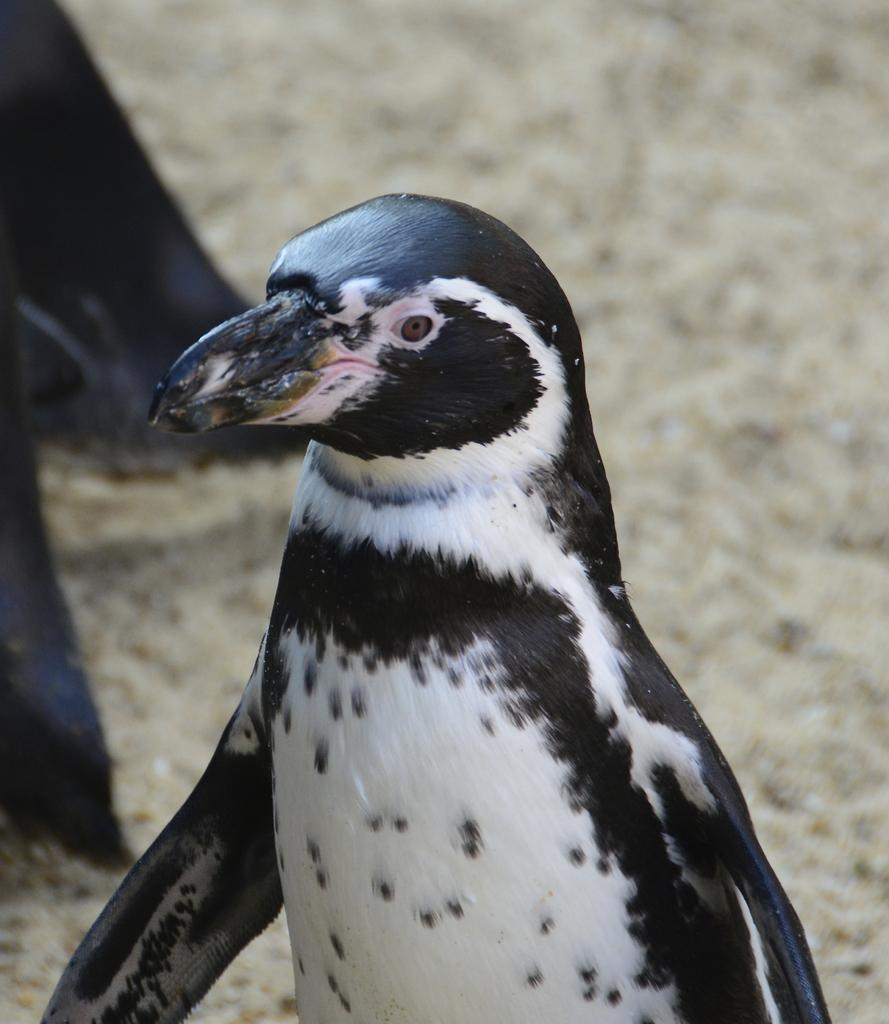What animal is the main subject of the image? There is a penguin in the image. Where is the penguin located in the image? The penguin is in the middle of the image. What colors can be seen on the penguin? The color of the penguin is black and white. What type of surface can be seen in the background of the image? There is ground visible in the background of the image. How much income does the penguin generate in the image? There is no information about income in the image, as it features a penguin and not a financial situation. 